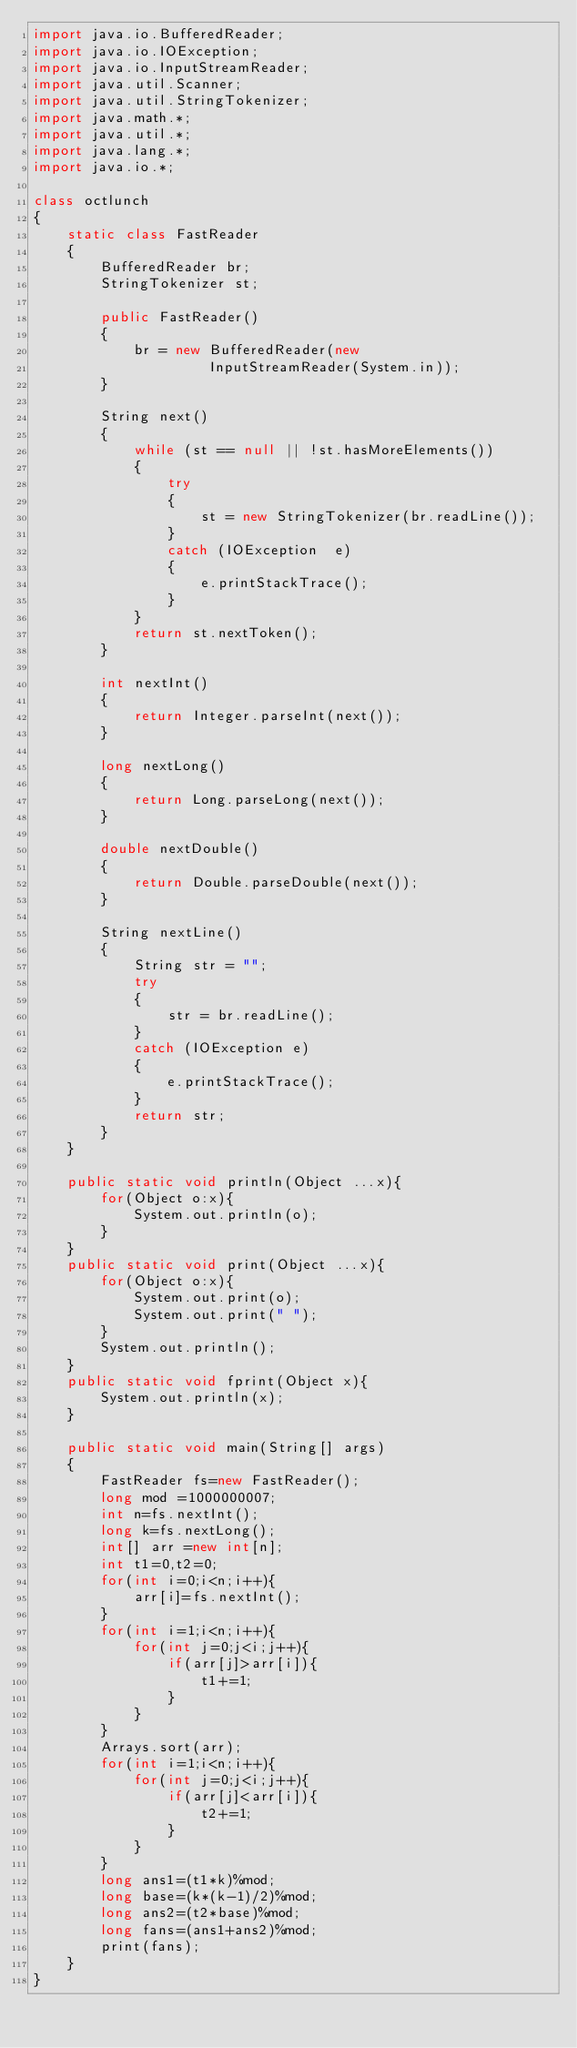<code> <loc_0><loc_0><loc_500><loc_500><_Java_>import java.io.BufferedReader; 
import java.io.IOException; 
import java.io.InputStreamReader; 
import java.util.Scanner; 
import java.util.StringTokenizer; 
import java.math.*;
import java.util.*;
import java.lang.*;
import java.io.*;

class octlunch
{ 
    static class FastReader 
    { 
        BufferedReader br; 
        StringTokenizer st; 
  
        public FastReader() 
        { 
            br = new BufferedReader(new
                     InputStreamReader(System.in)); 
        } 
  
        String next() 
        { 
            while (st == null || !st.hasMoreElements()) 
            { 
                try
                { 
                    st = new StringTokenizer(br.readLine()); 
                } 
                catch (IOException  e) 
                { 
                    e.printStackTrace(); 
                } 
            } 
            return st.nextToken(); 
        } 
  
        int nextInt() 
        { 
            return Integer.parseInt(next()); 
        } 
  
        long nextLong() 
        { 
            return Long.parseLong(next()); 
        } 
  
        double nextDouble() 
        { 
            return Double.parseDouble(next()); 
        } 
  
        String nextLine() 
        { 
            String str = ""; 
            try
            { 
                str = br.readLine(); 
            } 
            catch (IOException e) 
            { 
                e.printStackTrace(); 
            } 
            return str; 
        } 
    }
     
    public static void println(Object ...x){
        for(Object o:x){
            System.out.println(o);
        }
    }
    public static void print(Object ...x){
        for(Object o:x){
            System.out.print(o);
            System.out.print(" ");
        }
        System.out.println();
    }
    public static void fprint(Object x){
        System.out.println(x);
    }
    
    public static void main(String[] args) 
    { 
        FastReader fs=new FastReader();
        long mod =1000000007;
        int n=fs.nextInt();
        long k=fs.nextLong();
        int[] arr =new int[n];
        int t1=0,t2=0;
        for(int i=0;i<n;i++){
            arr[i]=fs.nextInt();
        }
        for(int i=1;i<n;i++){
            for(int j=0;j<i;j++){
                if(arr[j]>arr[i]){
                    t1+=1;
                }
            }
        }
        Arrays.sort(arr);
        for(int i=1;i<n;i++){
            for(int j=0;j<i;j++){
                if(arr[j]<arr[i]){
                    t2+=1;
                }
            }
        }
        long ans1=(t1*k)%mod;
        long base=(k*(k-1)/2)%mod;
        long ans2=(t2*base)%mod;
        long fans=(ans1+ans2)%mod;
        print(fans);
    } 
} 
</code> 